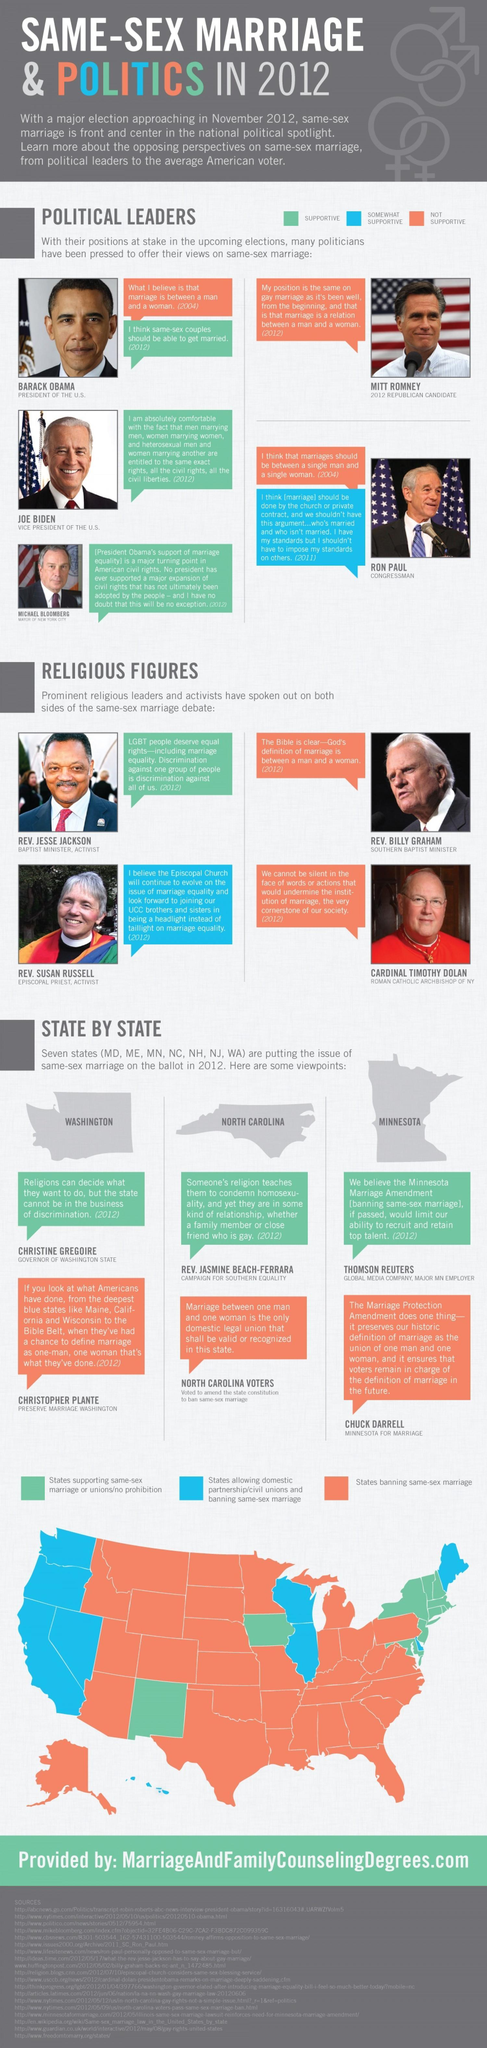How many political leaders have only one opinion about same-sex marriage?
Answer the question with a short phrase. 3 How many religious figures completely support same-sex marriage? 1 How many states support same-sex marriage? 3 How many states banned same-sex marriage? 3 How many political leaders have two opinions about same-sex marriage? 2 How many religious figures somewhat support same-sex marriage? 1 How many religious figures did not support same-sex marriage? 2 